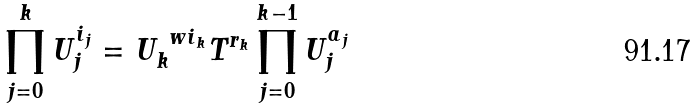<formula> <loc_0><loc_0><loc_500><loc_500>\prod _ { j = 0 } ^ { k } U _ { j } ^ { i _ { j } } = U _ { k } ^ { \ w i _ { k } } T ^ { r _ { k } } \prod _ { j = 0 } ^ { k - 1 } U _ { j } ^ { a _ { j } }</formula> 